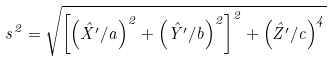<formula> <loc_0><loc_0><loc_500><loc_500>s ^ { 2 } = \sqrt { \left [ \left ( \hat { X } ^ { \prime } / a \right ) ^ { 2 } + \left ( \hat { Y } ^ { \prime } / b \right ) ^ { 2 } \right ] ^ { 2 } + \left ( \hat { Z } ^ { \prime } / c \right ) ^ { 4 } }</formula> 